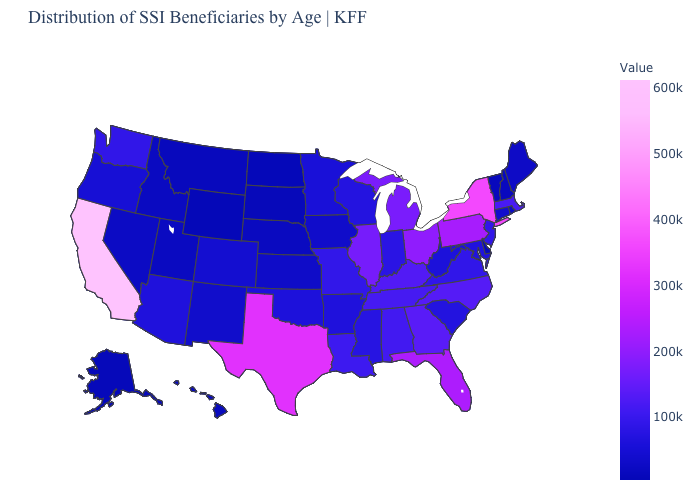Does Mississippi have the lowest value in the USA?
Answer briefly. No. Among the states that border Florida , does Georgia have the highest value?
Answer briefly. Yes. Does Wyoming have the lowest value in the West?
Concise answer only. Yes. 